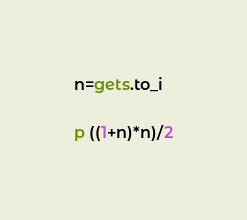<code> <loc_0><loc_0><loc_500><loc_500><_Ruby_>n=gets.to_i

p ((1+n)*n)/2</code> 